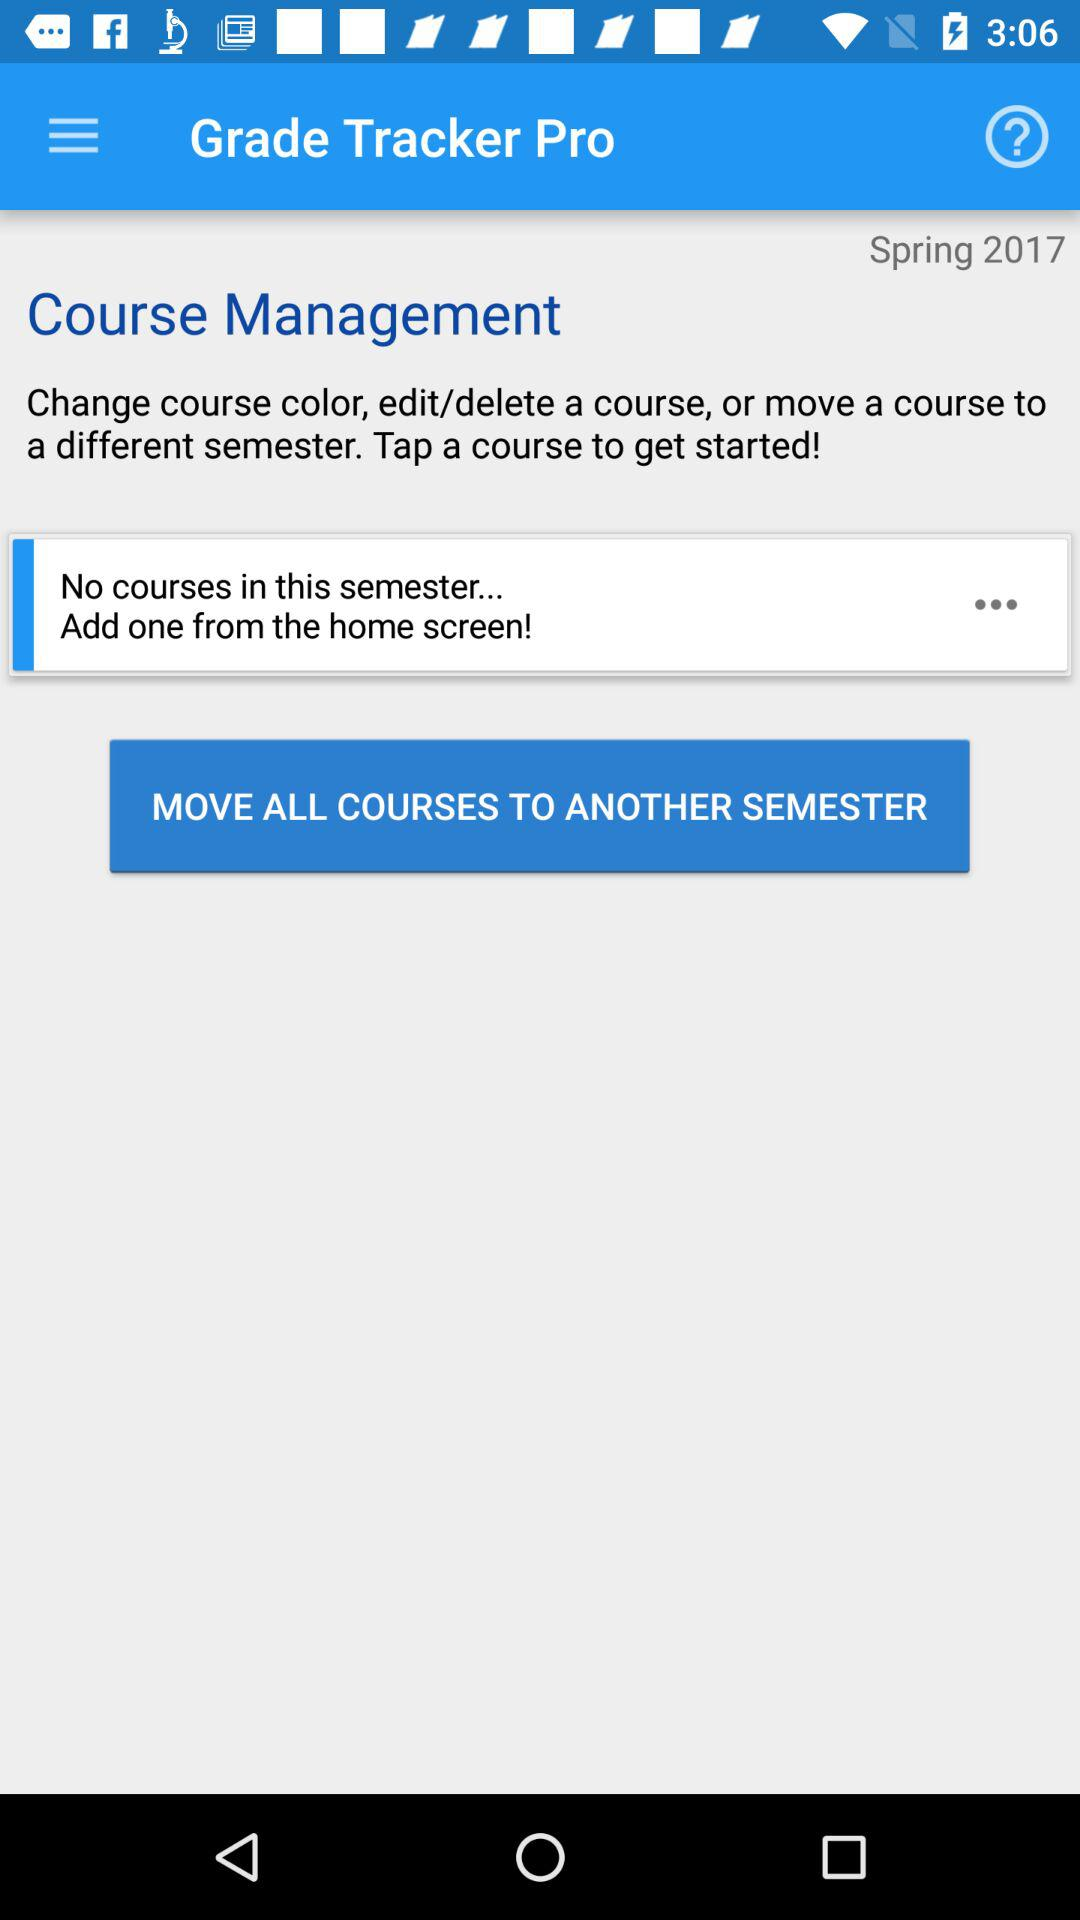How many courses are in the Spring 2017 semester?
Answer the question using a single word or phrase. 0 